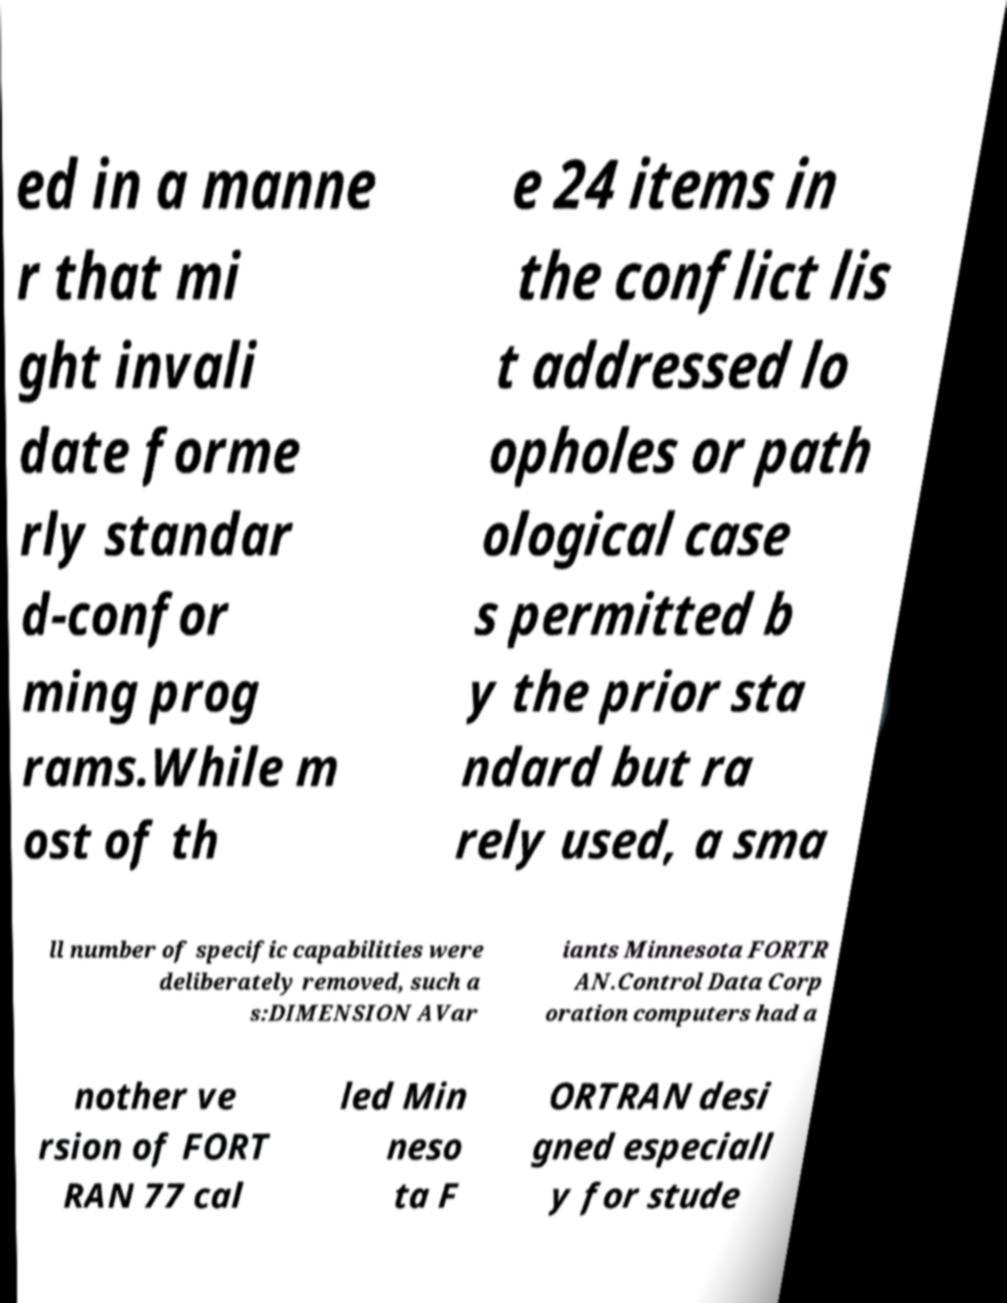For documentation purposes, I need the text within this image transcribed. Could you provide that? ed in a manne r that mi ght invali date forme rly standar d-confor ming prog rams.While m ost of th e 24 items in the conflict lis t addressed lo opholes or path ological case s permitted b y the prior sta ndard but ra rely used, a sma ll number of specific capabilities were deliberately removed, such a s:DIMENSION AVar iants Minnesota FORTR AN.Control Data Corp oration computers had a nother ve rsion of FORT RAN 77 cal led Min neso ta F ORTRAN desi gned especiall y for stude 